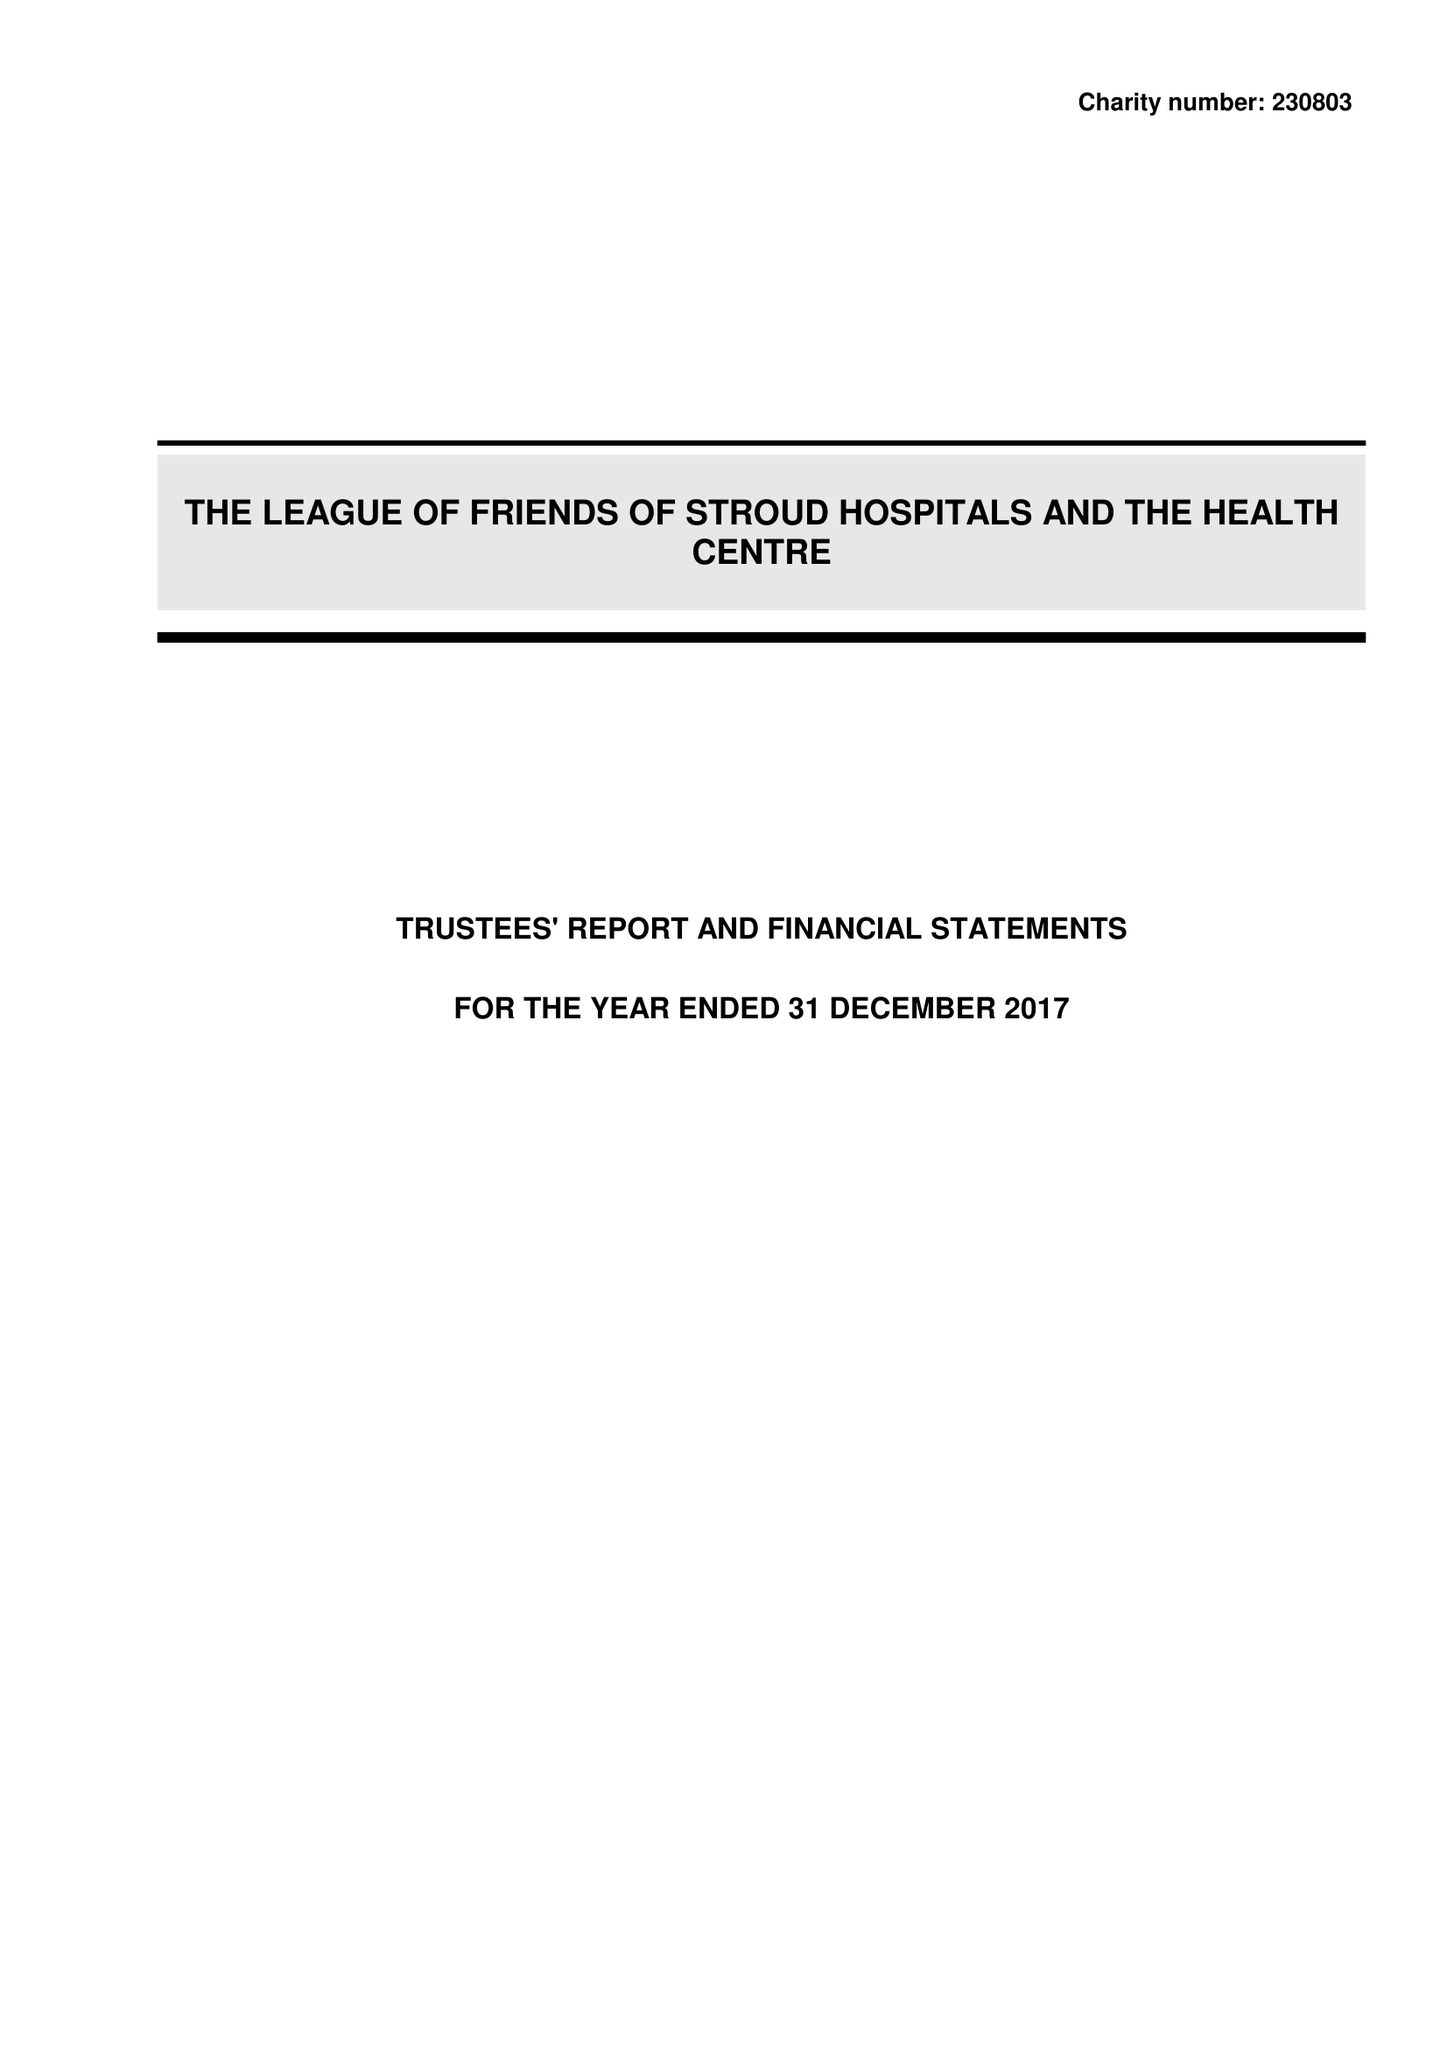What is the value for the address__street_line?
Answer the question using a single word or phrase. TRINITY ROAD 